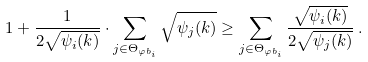<formula> <loc_0><loc_0><loc_500><loc_500>1 + \frac { 1 } { 2 \sqrt { \psi _ { i } ( k ) } } \cdot \sum _ { j \in \Theta _ { \varphi b _ { i } } } \sqrt { \psi _ { j } ( k ) } \geq \sum _ { j \in \Theta _ { \varphi b _ { i } } } \frac { \sqrt { \psi _ { i } ( k ) } } { 2 \sqrt { \psi _ { j } ( k ) } } \, .</formula> 